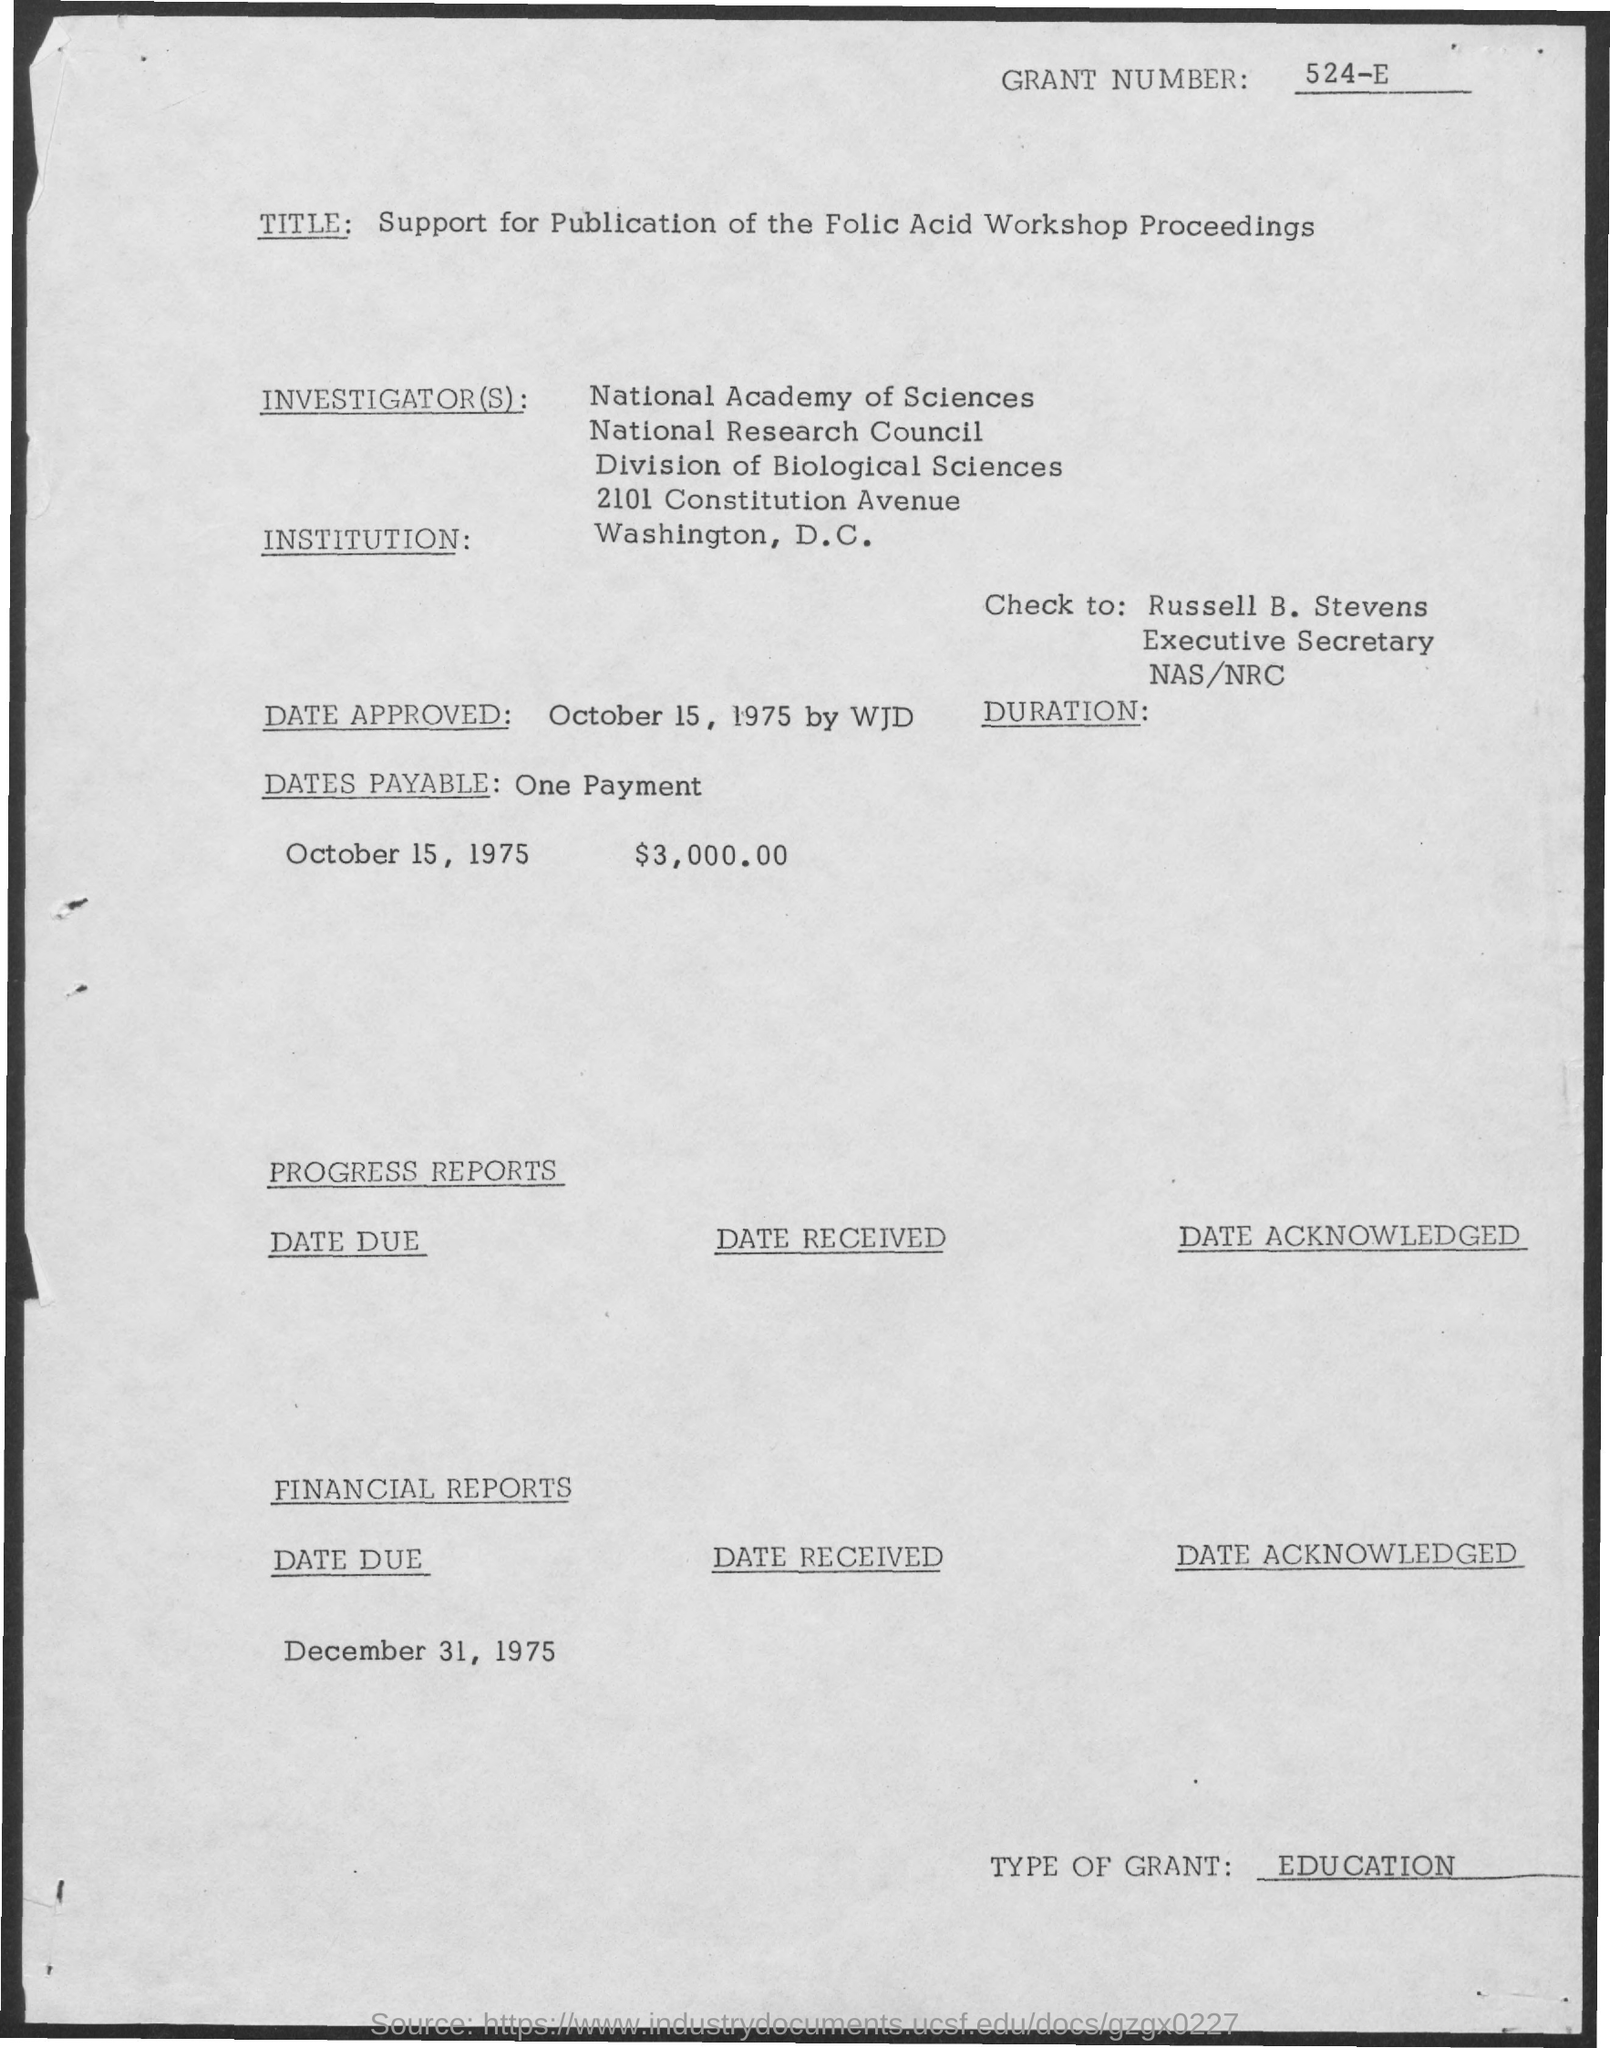Who is the Check to:?
Keep it short and to the point. Russell B. Stevens. What is the Dates Payable?
Make the answer very short. One payment. When is the Date Due?
Provide a short and direct response. December 31, 1975. 